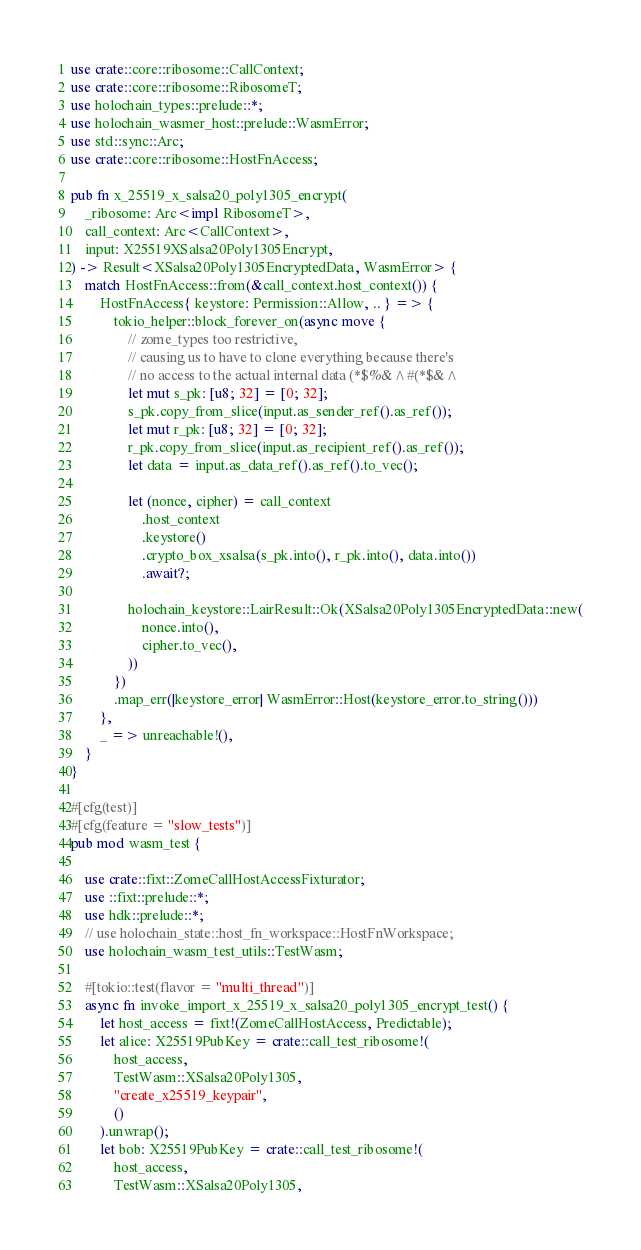Convert code to text. <code><loc_0><loc_0><loc_500><loc_500><_Rust_>use crate::core::ribosome::CallContext;
use crate::core::ribosome::RibosomeT;
use holochain_types::prelude::*;
use holochain_wasmer_host::prelude::WasmError;
use std::sync::Arc;
use crate::core::ribosome::HostFnAccess;

pub fn x_25519_x_salsa20_poly1305_encrypt(
    _ribosome: Arc<impl RibosomeT>,
    call_context: Arc<CallContext>,
    input: X25519XSalsa20Poly1305Encrypt,
) -> Result<XSalsa20Poly1305EncryptedData, WasmError> {
    match HostFnAccess::from(&call_context.host_context()) {
        HostFnAccess{ keystore: Permission::Allow, .. } => {
            tokio_helper::block_forever_on(async move {
                // zome_types too restrictive,
                // causing us to have to clone everything because there's
                // no access to the actual internal data (*$%&^#(*$&^
                let mut s_pk: [u8; 32] = [0; 32];
                s_pk.copy_from_slice(input.as_sender_ref().as_ref());
                let mut r_pk: [u8; 32] = [0; 32];
                r_pk.copy_from_slice(input.as_recipient_ref().as_ref());
                let data = input.as_data_ref().as_ref().to_vec();

                let (nonce, cipher) = call_context
                    .host_context
                    .keystore()
                    .crypto_box_xsalsa(s_pk.into(), r_pk.into(), data.into())
                    .await?;

                holochain_keystore::LairResult::Ok(XSalsa20Poly1305EncryptedData::new(
                    nonce.into(),
                    cipher.to_vec(),
                ))
            })
            .map_err(|keystore_error| WasmError::Host(keystore_error.to_string()))
        },
        _ => unreachable!(),
    }
}

#[cfg(test)]
#[cfg(feature = "slow_tests")]
pub mod wasm_test {

    use crate::fixt::ZomeCallHostAccessFixturator;
    use ::fixt::prelude::*;
    use hdk::prelude::*;
    // use holochain_state::host_fn_workspace::HostFnWorkspace;
    use holochain_wasm_test_utils::TestWasm;

    #[tokio::test(flavor = "multi_thread")]
    async fn invoke_import_x_25519_x_salsa20_poly1305_encrypt_test() {
        let host_access = fixt!(ZomeCallHostAccess, Predictable);
        let alice: X25519PubKey = crate::call_test_ribosome!(
            host_access,
            TestWasm::XSalsa20Poly1305,
            "create_x25519_keypair",
            ()
        ).unwrap();
        let bob: X25519PubKey = crate::call_test_ribosome!(
            host_access,
            TestWasm::XSalsa20Poly1305,</code> 